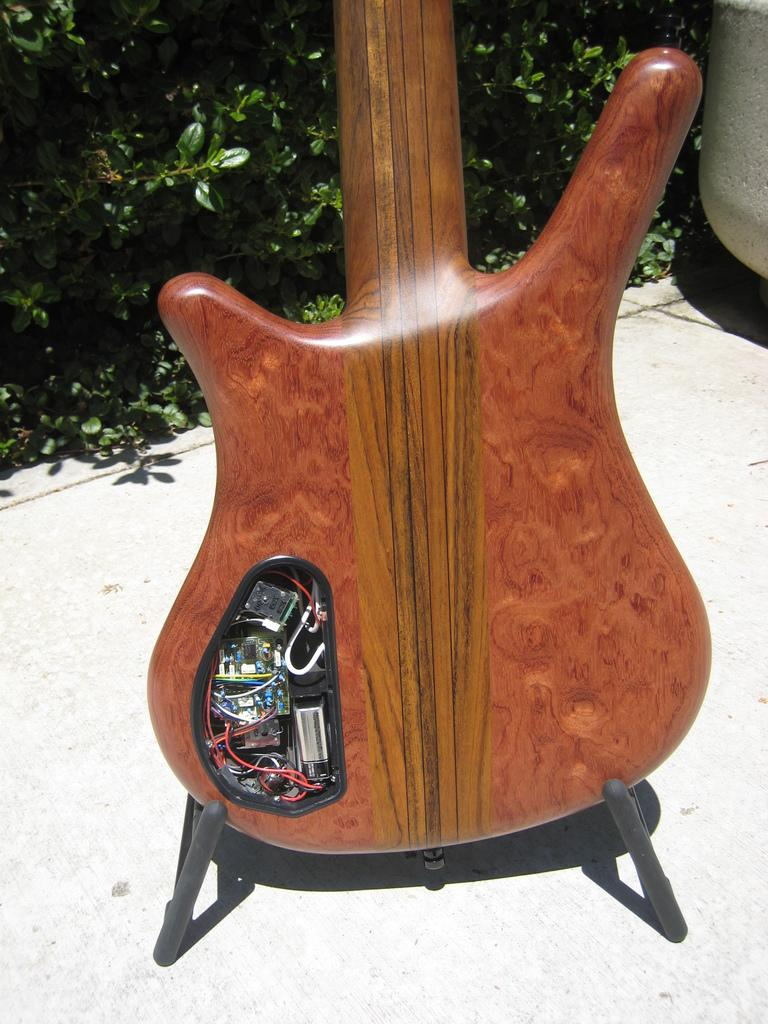What musical instrument is placed on the floor in the image? There is a guitar on the floor in the image. What type of pet can be seen grazing on the grass in the image? There is no pet or grass present in the image; it features a guitar on the floor. What type of growth can be observed on the sheep in the image? There is no sheep or growth present in the image; it features a guitar on the floor. 